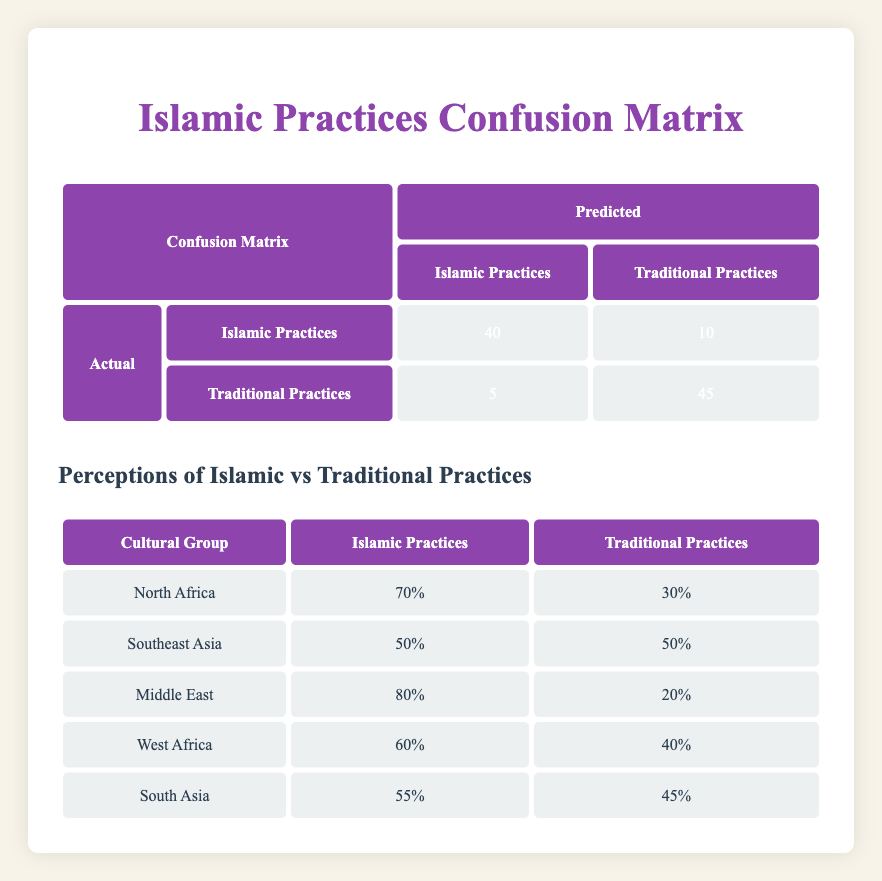What is the true positive rate for Islamic Practices? The true positive rate is calculated by taking the number of true positives and dividing it by the total number of actual Islamic Practices. From the table, there are 40 true positives and 10 false negatives. So, the total actual Islamic Practices is 40 + 10 = 50. The true positive rate is therefore 40/50 = 0.8 or 80%.
Answer: 80% How many respondents perceived Traditional Practices positively? The table shows that there are 45 true negatives, which means 45 respondents accurately perceived Traditional Practices when compared to the actual status.
Answer: 45 Which cultural group has the highest perception of Islamic Practices? Looking at the perceptions table, the Middle East has the highest percentage of Islamic Practices at 80%.
Answer: Middle East What is the percentage of Southeast Asia respondents that perceived Traditional Practices? According to the perceptions table, Southeast Asia has a perception of Traditional Practices at 50%.
Answer: 50% Did West Africa respondents perceive Islamic Practices more than Traditional Practices? In the perceptions table, West Africa shows 60% for Islamic Practices and 40% for Traditional Practices. Since 60% is greater than 40%, the answer is yes.
Answer: Yes What is the difference in perception percentages between Islamic Practices and Traditional Practices in South Asia? The perception for Islamic Practices in South Asia is 55% and for Traditional Practices is 45%. The difference is calculated as 55% - 45% = 10%.
Answer: 10% Is it true that fewer respondents in North Africa perceived Traditional Practices than Islamic Practices? The perceptions indicate that North Africa has 70% for Islamic Practices and 30% for Traditional Practices. Since 30% is indeed less than 70%, the statement is true.
Answer: True What is the average percentage perception of Traditional Practices across all cultural groups? The percentages for Traditional Practices in each group are: North Africa (30%), Southeast Asia (50%), Middle East (20%), West Africa (40%), and South Asia (45%). To find the average, sum these values: 30 + 50 + 20 + 40 + 45 = 185, and divide by the number of groups (5): 185/5 = 37%.
Answer: 37% 